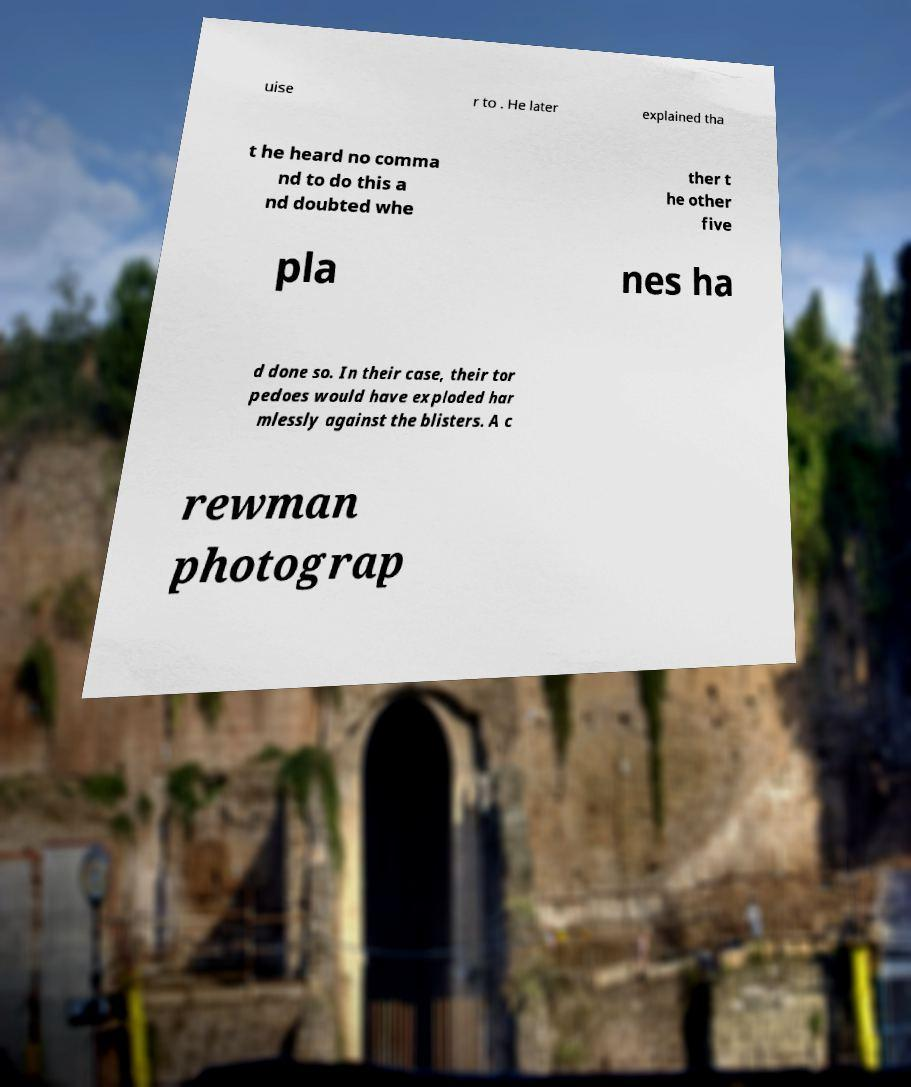Can you read and provide the text displayed in the image?This photo seems to have some interesting text. Can you extract and type it out for me? uise r to . He later explained tha t he heard no comma nd to do this a nd doubted whe ther t he other five pla nes ha d done so. In their case, their tor pedoes would have exploded har mlessly against the blisters. A c rewman photograp 